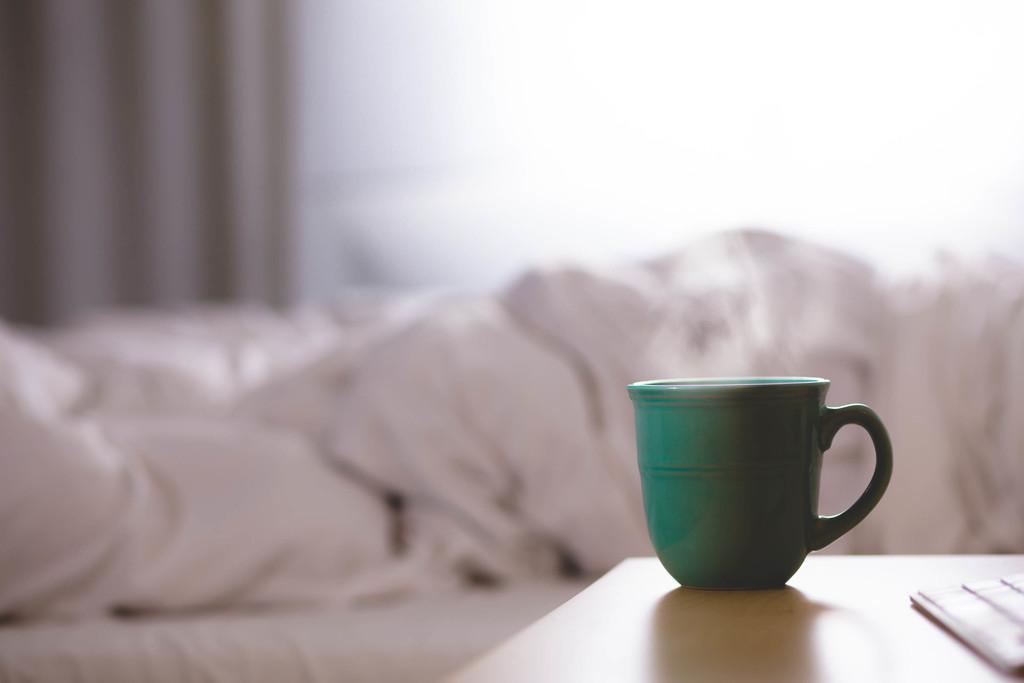Describe this image in one or two sentences. The image is inside the room. In the image there is a cup on table, on table we can see a keyboard in background there is a white color bed and curtain. 